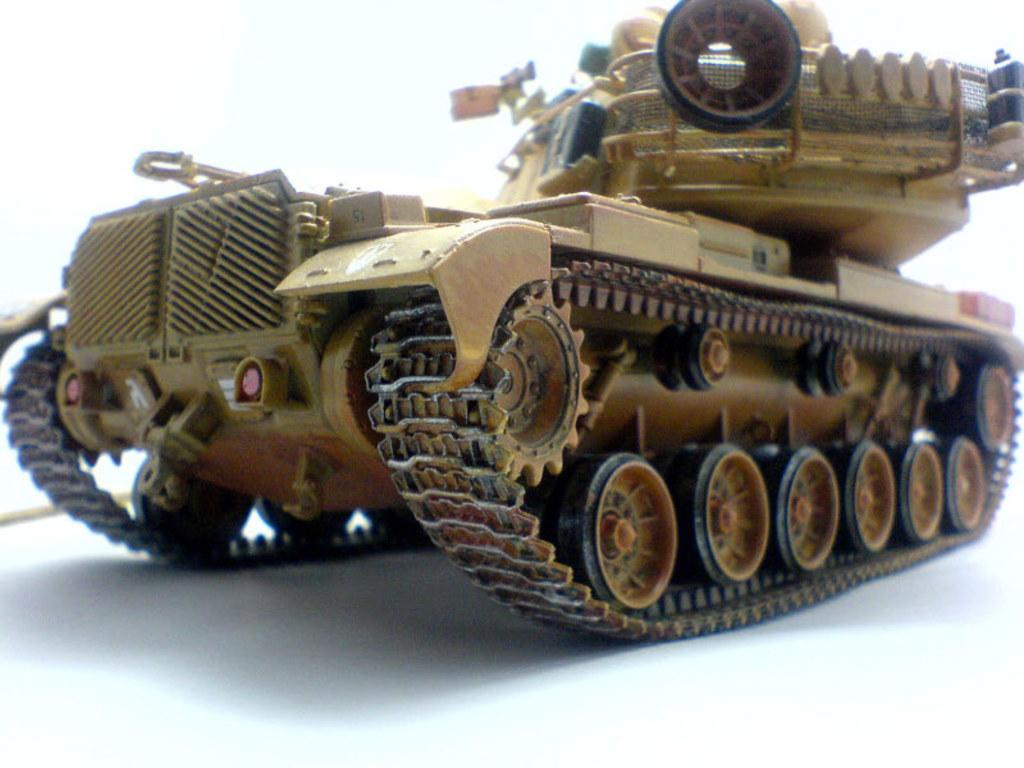What type of toy is in the image? There is a toy war tank in the image. What is the toy war tank placed on? The toy war tank is on a white surface. What color is the background of the image? The background of the image is white. What type of heart is visible in the image? There is no heart present in the image; it features a toy war tank on a white surface with a white background. 